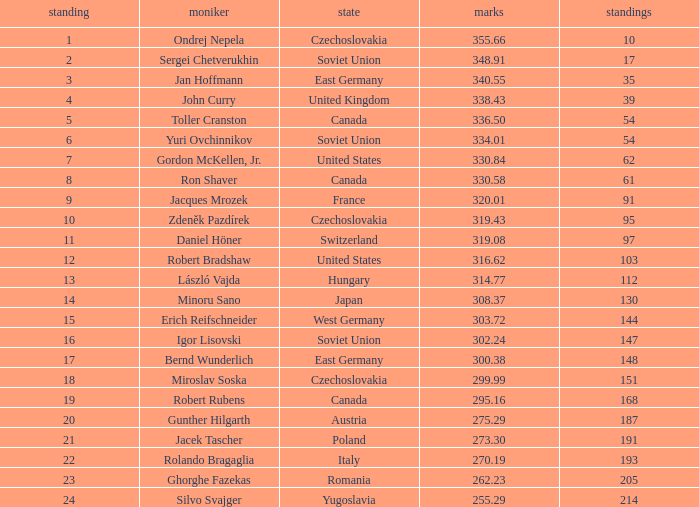Which Rank has a Name of john curry, and Points larger than 338.43? None. 